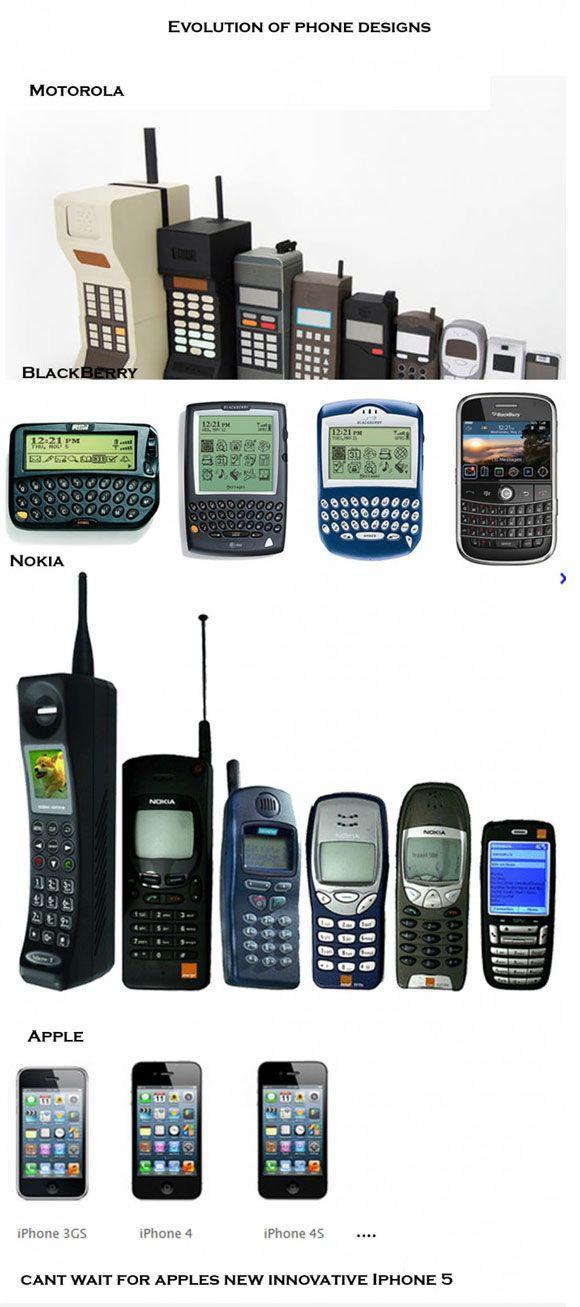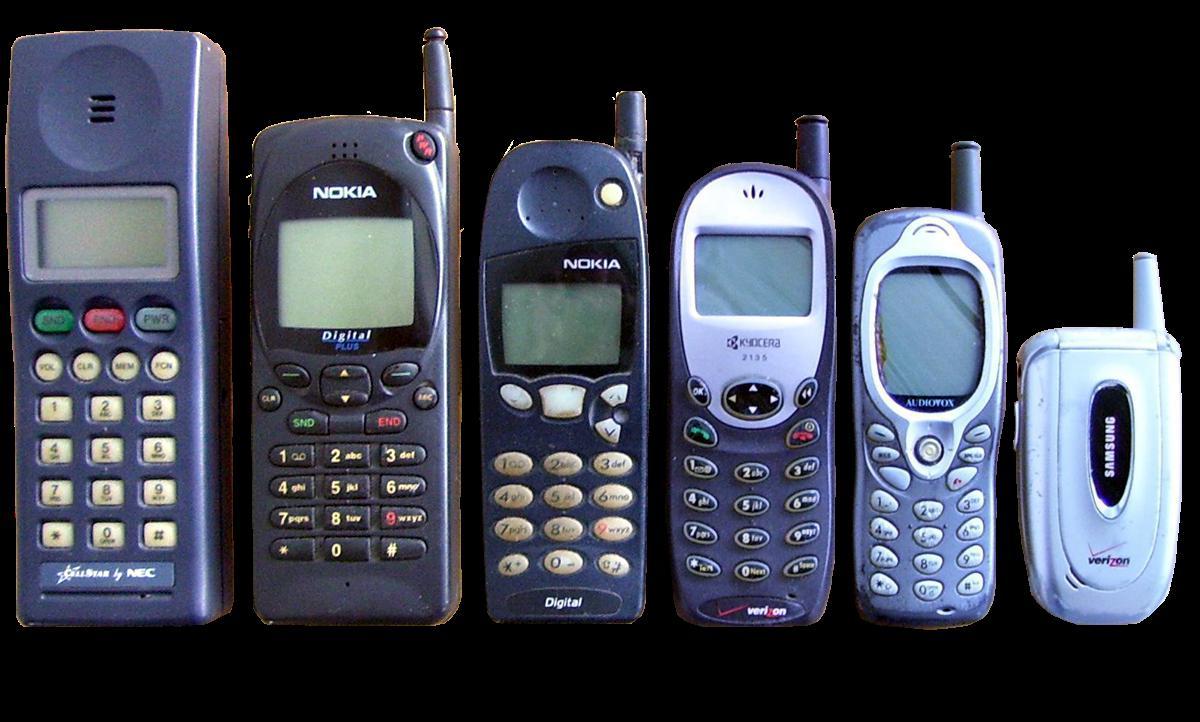The first image is the image on the left, the second image is the image on the right. Evaluate the accuracy of this statement regarding the images: "Each image includes a horizontal row of various cell phones displayed upright in size order.". Is it true? Answer yes or no. Yes. The first image is the image on the left, the second image is the image on the right. For the images displayed, is the sentence "At least one phone is upright next to a box." factually correct? Answer yes or no. No. 